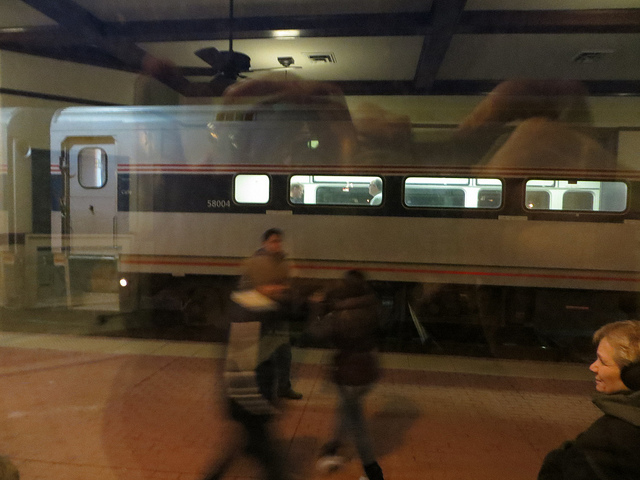Read all the text in this image. 58004 